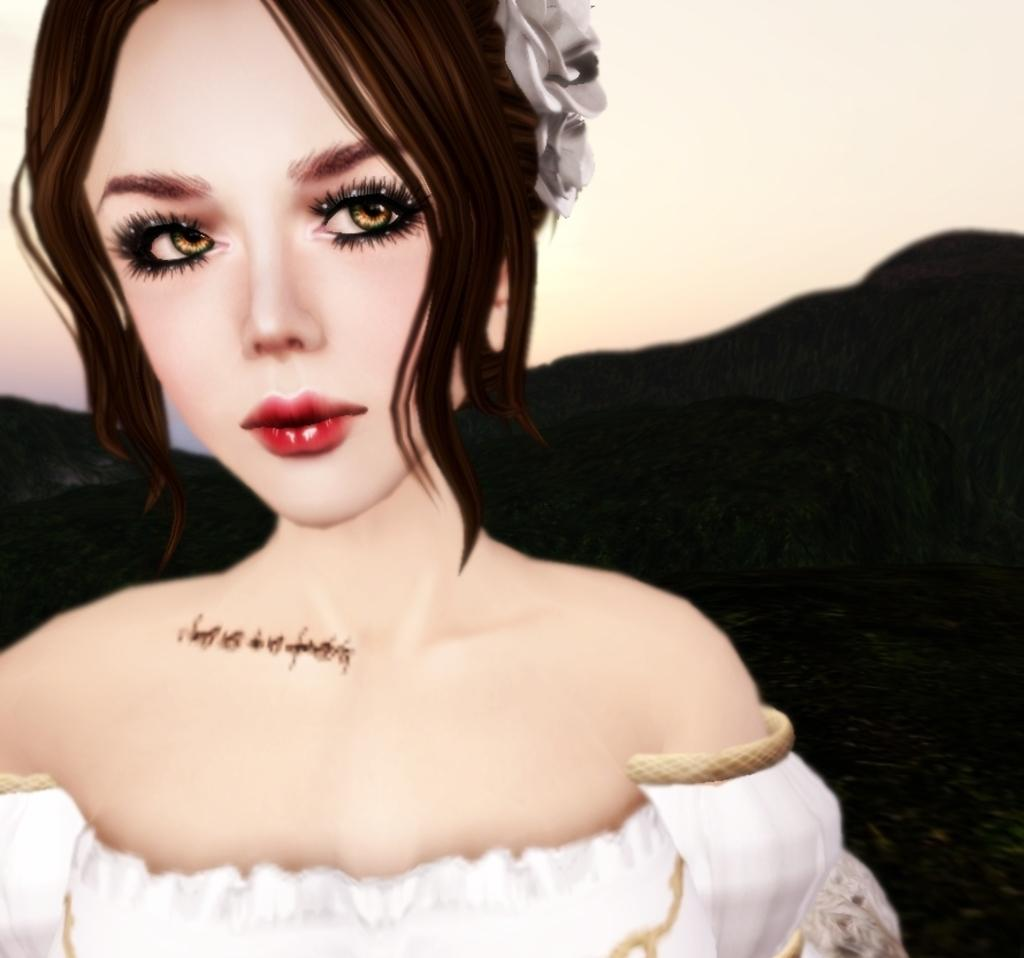What type of artwork is depicted in the image? The image is a painting. Can you describe the main subject of the painting? There is a lady in the center of the painting. What can be observed about the background of the painting? There is a dark and light color in the background of the painting. How many carts are visible in the painting? There are no carts present in the painting; it features a lady and a background with dark and light colors. What type of snake can be seen slithering in the background of the painting? There is no snake present in the painting; it only features a lady and a background with dark and light colors. 